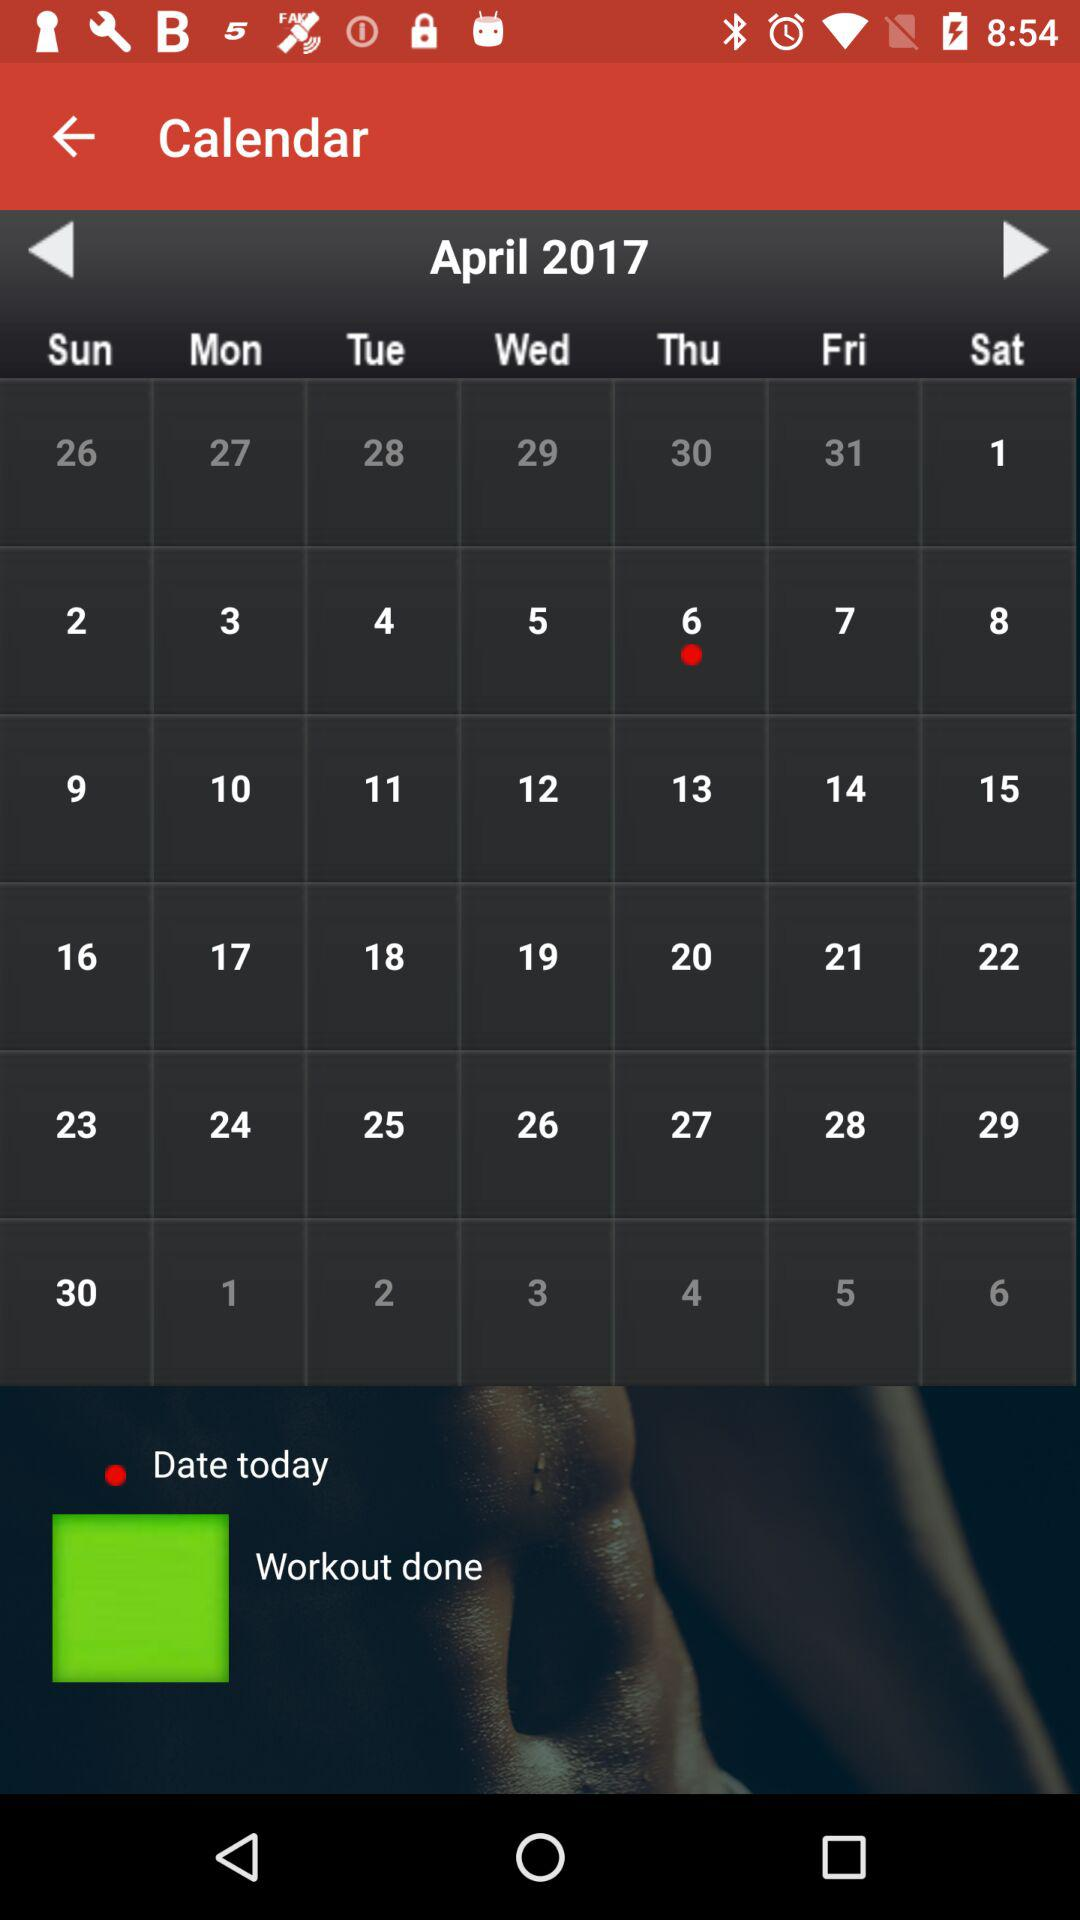What is the given year? The given year is 2017. 